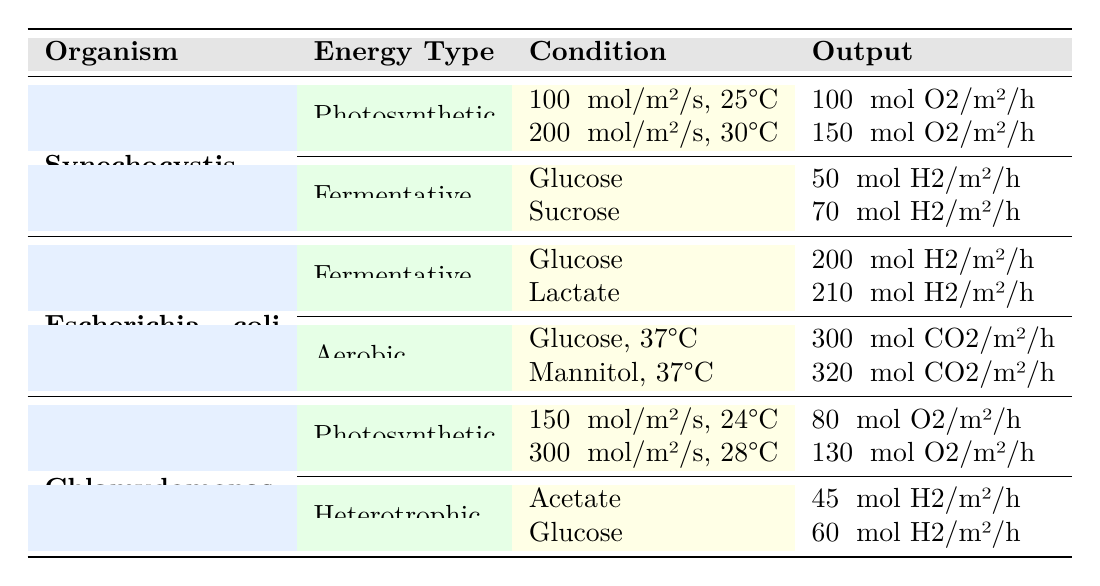What is the energy output of Synechocystis sp. PCC 6803 under photosynthetic conditions at 200 μmol/m²/s and 30°C? The table lists the energy output for Synechocystis sp. PCC 6803 under photosynthetic conditions. Specifically, for the conditions of 200 μmol/m²/s and 30°C, the output is 150 μmol O2/m²/h.
Answer: 150 μmol O2/m²/h What is the energy output of Escherichia coli (modified) using glucose as a carbon source under aerobic conditions? For Escherichia coli (modified), the aerobic conditions with glucose result in an output of 300 μmol CO2/m²/h as indicated in the table.
Answer: 300 μmol CO2/m²/h Which organism produces the highest output under fermentative conditions? By comparing the outputs for the fermentative conditions of each organism, Escherichia coli (modified) outputs 210 μmol H2/m²/h with lactate, which is higher than Synechocystis sp. PCC 6803 and Chlamydomonas reinhardtii. Thus, Escherichia coli (modified) has the highest output under these conditions.
Answer: Escherichia coli (modified) What is the average energy output of Chlamydomonas reinhardtii under photosynthetic conditions? The outputs under photosynthetic conditions for Chlamydomonas reinhardtii are 80 μmol O2/m²/h at 150 μmol/m²/s, 24°C and 130 μmol O2/m²/h at 300 μmol/m²/s, 28°C. To find the average, we sum these outputs (80 + 130 = 210 μmol O2/m²/h) and divide by the number of conditions (2), yielding an average output of 105 μmol O2/m²/h.
Answer: 105 μmol O2/m²/h Does Chlamydomonas reinhardtii have a higher output under photosynthetic or heterotrophic conditions? Under photosynthetic conditions, Chlamydomonas reinhardtii outputs a maximum of 130 μmol O2/m²/h, and under heterotrophic conditions, the maximum output is 60 μmol H2/m²/h. Since 130 is greater than 60, the answer is yes; Chlamydomonas reinhardtii has a higher output under photosynthetic conditions.
Answer: Yes What is the energy output of Synechocystis sp. PCC 6803 when using sucrose as a carbon source? The output for Synechocystis sp. PCC 6803 when using sucrose, as listed in the table under fermentative conditions, is 70 μmol H2/m²/h.
Answer: 70 μmol H2/m²/h 